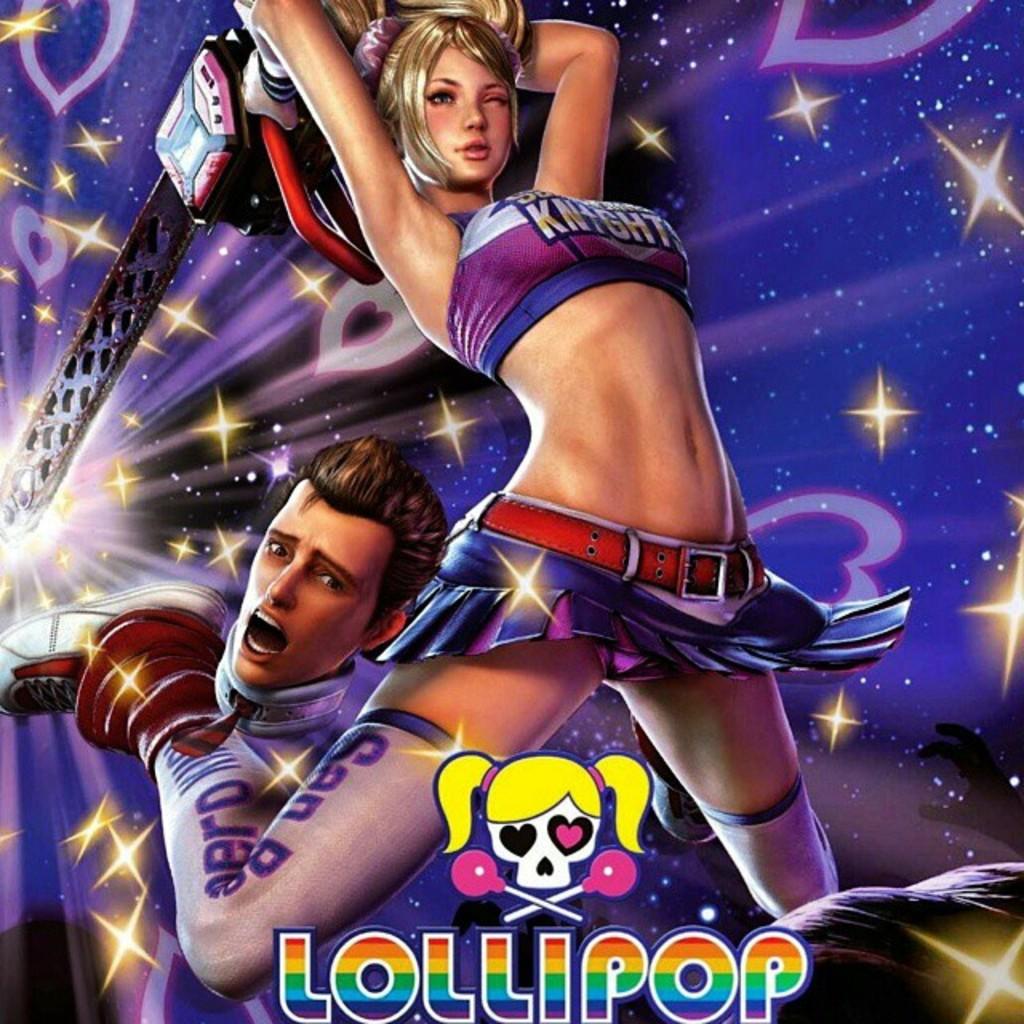What is the name of the candy that is also the name of this game?
Offer a terse response. Lollipop. What type of medieval warrior is written on the girl's top?
Provide a short and direct response. Knight. 